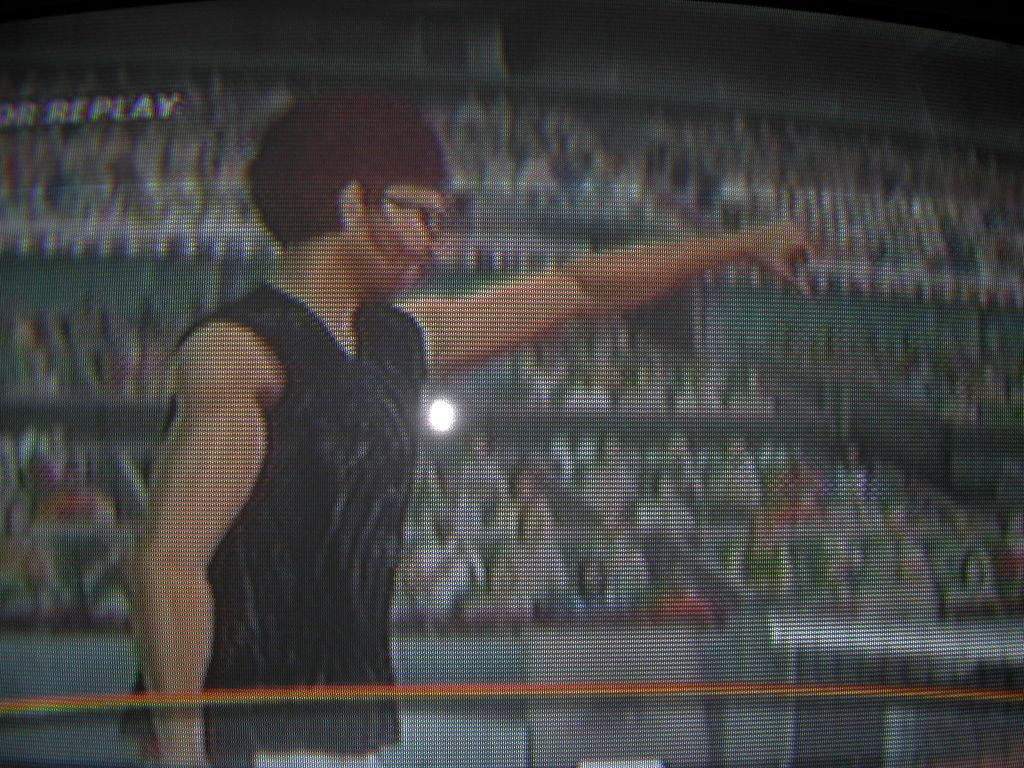What is the main subject in the foreground of the image? There is a man standing in the foreground of the image. What is the man doing in the image? The man is stretching his hand. What can be seen in the background of the image? There is an audience in the background of the image. What type of reward is the man holding in his hand in the image? There is no reward visible in the man's hand in the image. What type of fuel is being used by the audience in the background? There is no mention of fuel or any related activity in the image. 